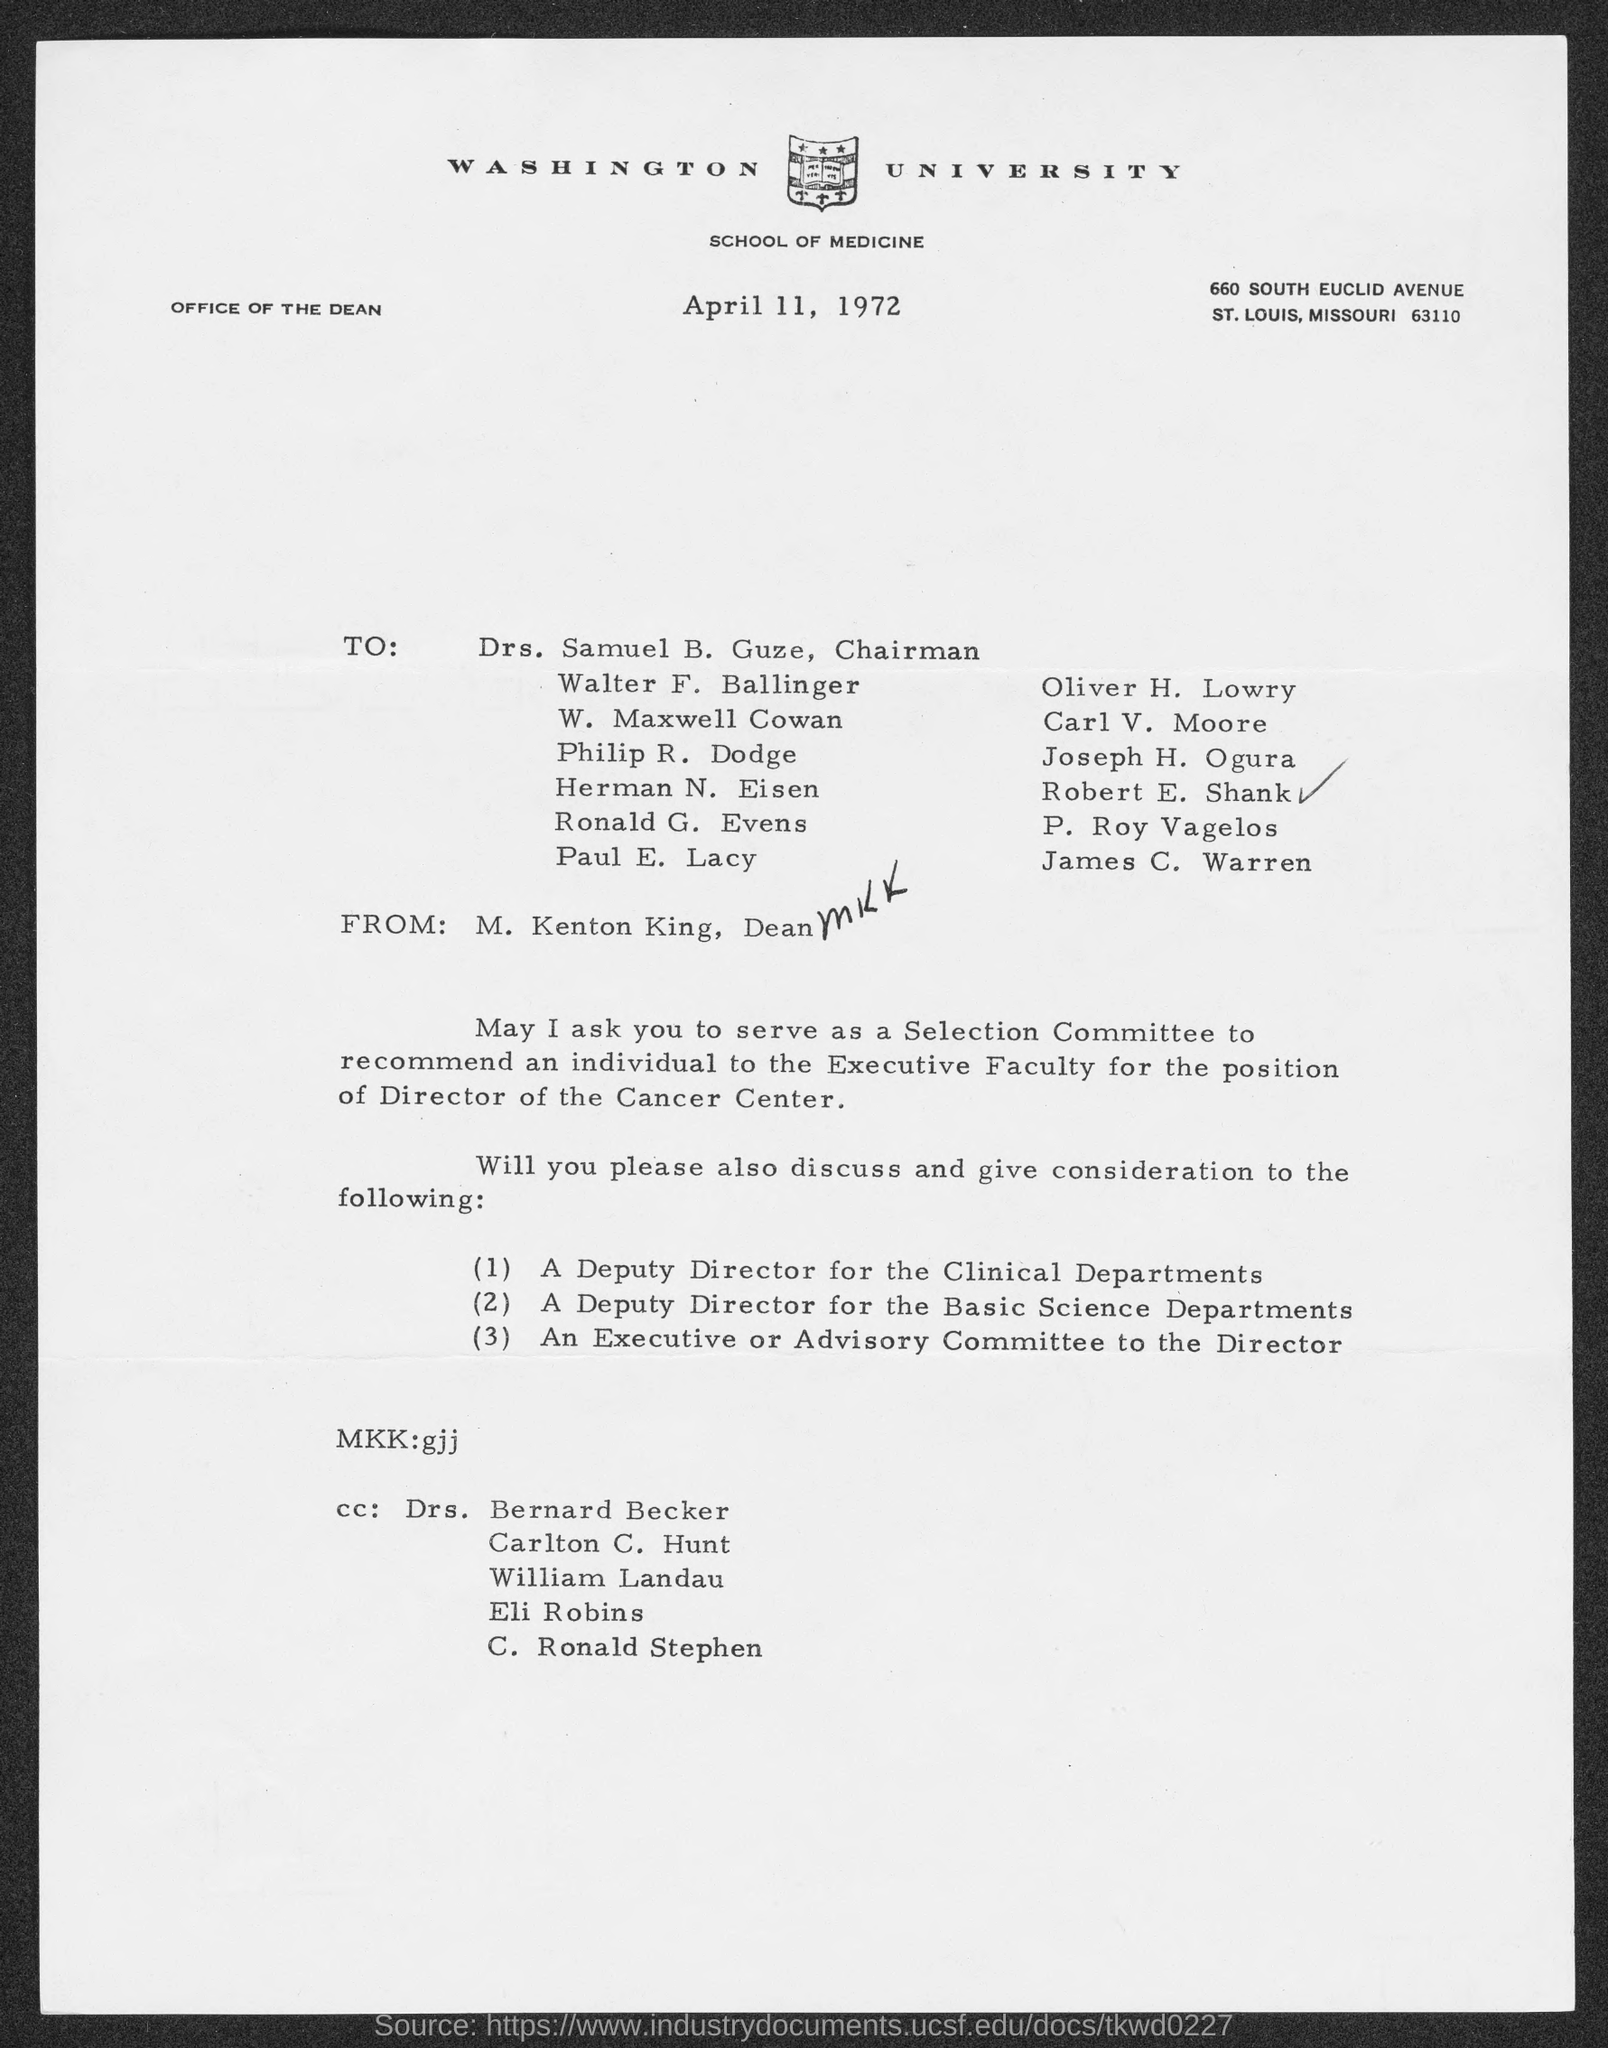Which university is mentioned in the letter head?
Make the answer very short. WASHINGTON UNIVERSITY. What is the date mentioned in this letter?
Provide a short and direct response. April 11, 1972. 